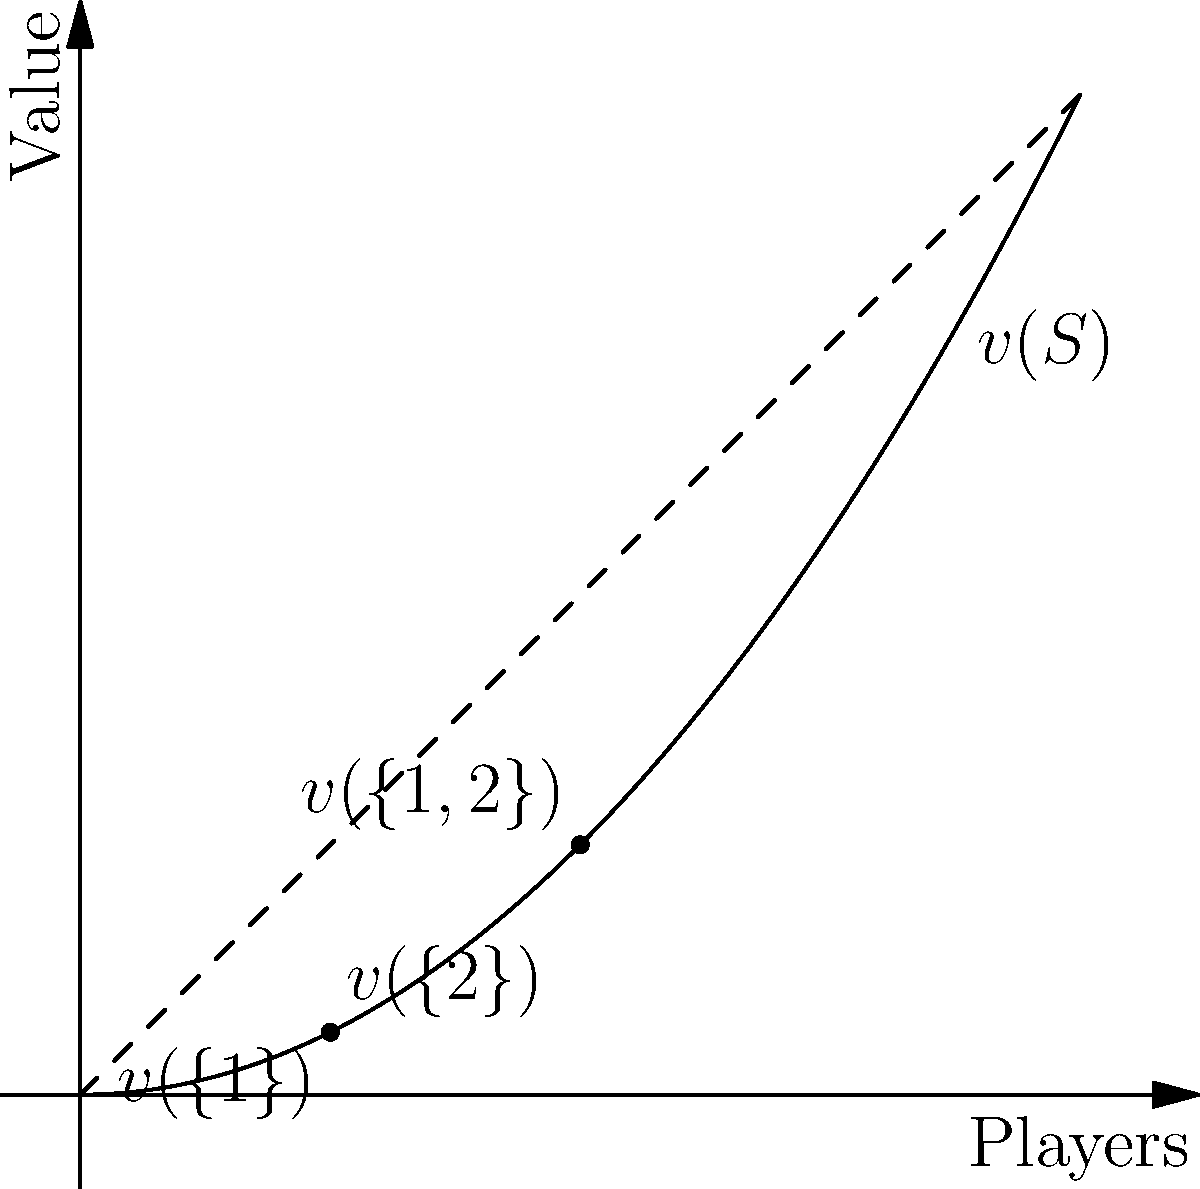Consider a two-player cooperative game with the characteristic function depicted in the graph above. The x-axis represents the number of players, and the y-axis represents the value generated. Calculate the Shapley value for player 1 in this game. To calculate the Shapley value for player 1, we need to follow these steps:

1) Identify the values:
   $v(\{1\}) = 0.25$
   $v(\{2\}) = 0.25$
   $v(\{1,2\}) = 1$

2) Calculate the marginal contributions of player 1:
   - When player 1 joins first: $v(\{1\}) - v(\emptyset) = 0.25 - 0 = 0.25$
   - When player 1 joins second: $v(\{1,2\}) - v(\{2\}) = 1 - 0.25 = 0.75$

3) Apply the Shapley value formula:
   $\phi_1(v) = \frac{1}{2!}[\frac{1!0!}{2!}(0.25) + \frac{0!1!}{2!}(0.75)]$

4) Simplify:
   $\phi_1(v) = \frac{1}{2}[\frac{1}{2}(0.25) + \frac{1}{2}(0.75)]$
   $\phi_1(v) = \frac{1}{2}[0.125 + 0.375]$
   $\phi_1(v) = \frac{1}{2}[0.5]$
   $\phi_1(v) = 0.25$

Therefore, the Shapley value for player 1 is 0.25.
Answer: $0.25$ 